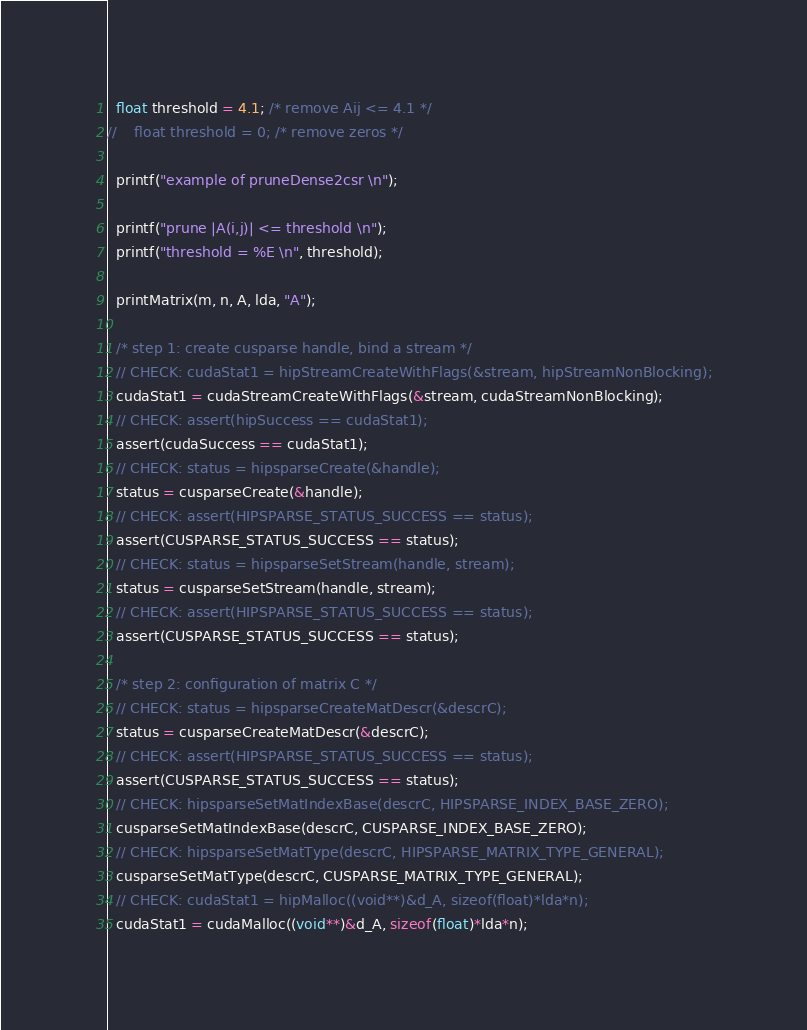<code> <loc_0><loc_0><loc_500><loc_500><_Cuda_>  float threshold = 4.1; /* remove Aij <= 4.1 */
//    float threshold = 0; /* remove zeros */

  printf("example of pruneDense2csr \n");

  printf("prune |A(i,j)| <= threshold \n");
  printf("threshold = %E \n", threshold);

  printMatrix(m, n, A, lda, "A");

  /* step 1: create cusparse handle, bind a stream */
  // CHECK: cudaStat1 = hipStreamCreateWithFlags(&stream, hipStreamNonBlocking);
  cudaStat1 = cudaStreamCreateWithFlags(&stream, cudaStreamNonBlocking);
  // CHECK: assert(hipSuccess == cudaStat1);
  assert(cudaSuccess == cudaStat1);
  // CHECK: status = hipsparseCreate(&handle);
  status = cusparseCreate(&handle);
  // CHECK: assert(HIPSPARSE_STATUS_SUCCESS == status);
  assert(CUSPARSE_STATUS_SUCCESS == status);
  // CHECK: status = hipsparseSetStream(handle, stream);
  status = cusparseSetStream(handle, stream);
  // CHECK: assert(HIPSPARSE_STATUS_SUCCESS == status);
  assert(CUSPARSE_STATUS_SUCCESS == status);

  /* step 2: configuration of matrix C */
  // CHECK: status = hipsparseCreateMatDescr(&descrC);
  status = cusparseCreateMatDescr(&descrC);
  // CHECK: assert(HIPSPARSE_STATUS_SUCCESS == status);
  assert(CUSPARSE_STATUS_SUCCESS == status);
  // CHECK: hipsparseSetMatIndexBase(descrC, HIPSPARSE_INDEX_BASE_ZERO);
  cusparseSetMatIndexBase(descrC, CUSPARSE_INDEX_BASE_ZERO);
  // CHECK: hipsparseSetMatType(descrC, HIPSPARSE_MATRIX_TYPE_GENERAL);
  cusparseSetMatType(descrC, CUSPARSE_MATRIX_TYPE_GENERAL);
  // CHECK: cudaStat1 = hipMalloc((void**)&d_A, sizeof(float)*lda*n);
  cudaStat1 = cudaMalloc((void**)&d_A, sizeof(float)*lda*n);</code> 